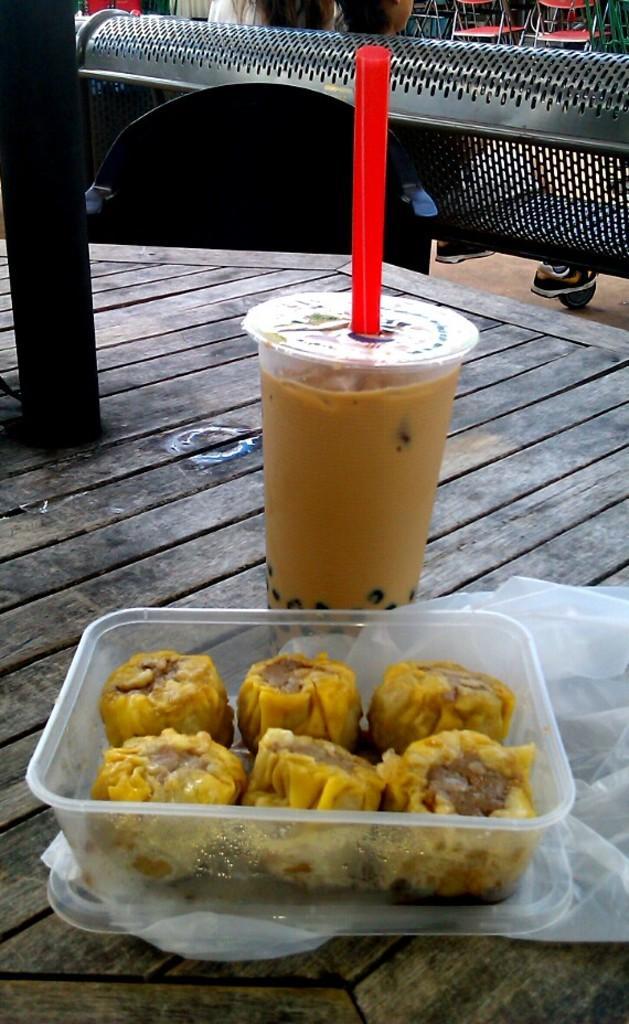In one or two sentences, can you explain what this image depicts? In this image I can see few food items in the box and the food items are in yellow color and I can also see the glass on the wooden surface. In the background I can see few people sitting and few chairs. 